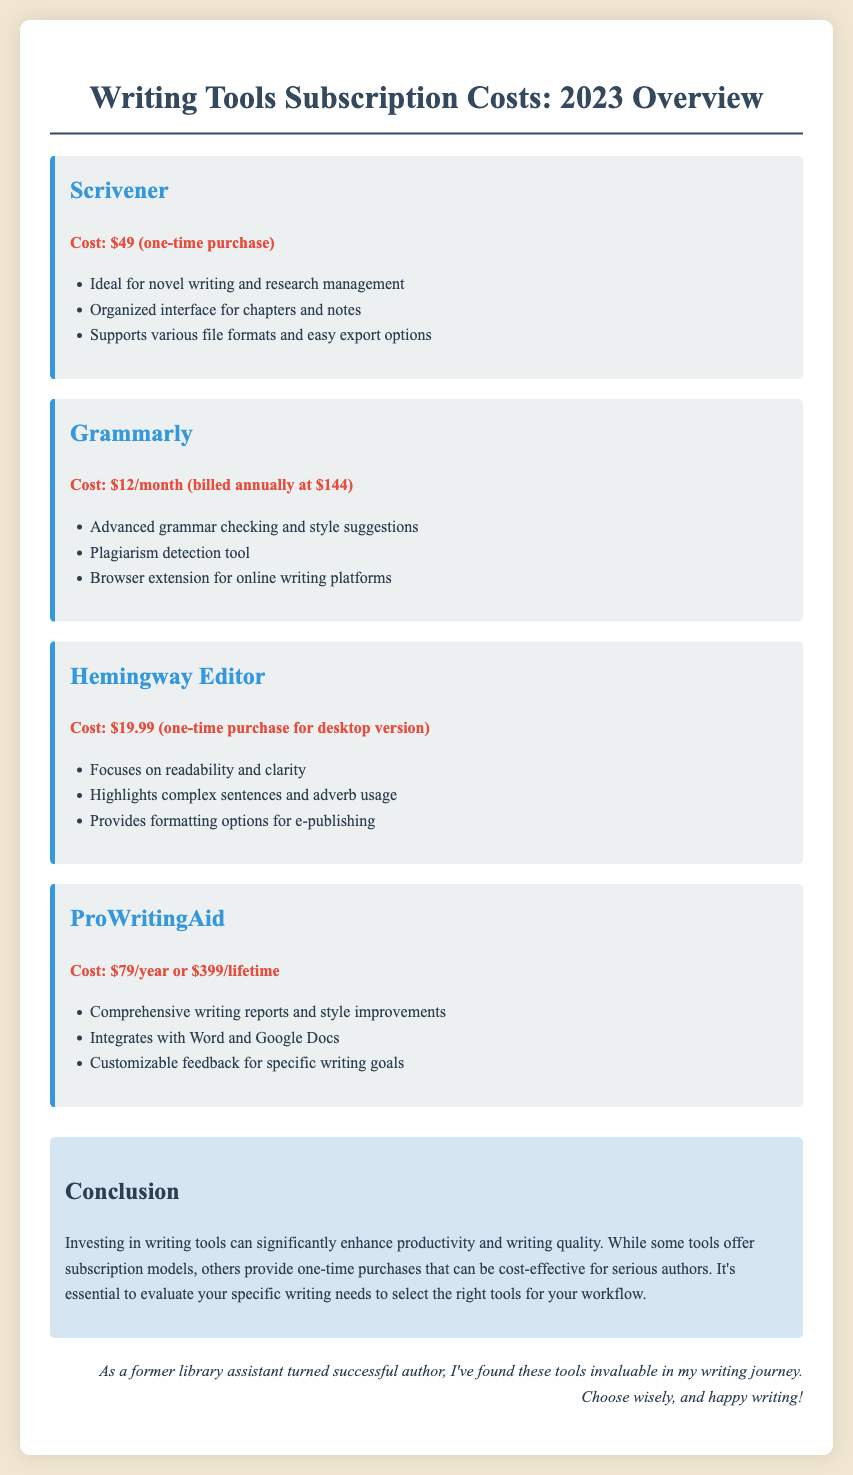What is the cost of Scrivener? Scrivener has a one-time purchase cost listed in the document, which is $49.
Answer: $49 What is the monthly cost of Grammarly? Grammarly's annual plan is billed monthly, which amounts to $12 each month.
Answer: $12/month What feature does Hemingway Editor focus on? The document highlights that Hemingway Editor focuses on readability and clarity as its main feature.
Answer: Readability and clarity What is the one-time purchase price for Hemingway Editor? The document states that Hemingway Editor costs $19.99 for the desktop version as a one-time purchase.
Answer: $19.99 How much does ProWritingAid cost for a lifetime subscription? The document provides the lifetime subscription cost for ProWritingAid, which is $399.
Answer: $399 Which tool offers a plagiarism detection feature? According to the document, Grammarly includes a plagiarism detection tool as one of its features.
Answer: Grammarly What is the primary benefit of using ProWritingAid? The document notes that ProWritingAid provides comprehensive writing reports and style improvements.
Answer: Comprehensive writing reports and style improvements What type of purchase option is available for Scrivener? The document indicates that Scrivener is available as a one-time purchase option.
Answer: One-time purchase What is the overall conclusion regarding writing tools in the document? The conclusion emphasizes that investing in writing tools enhances productivity and writing quality, suggesting careful selection based on writing needs.
Answer: Enhance productivity and writing quality 